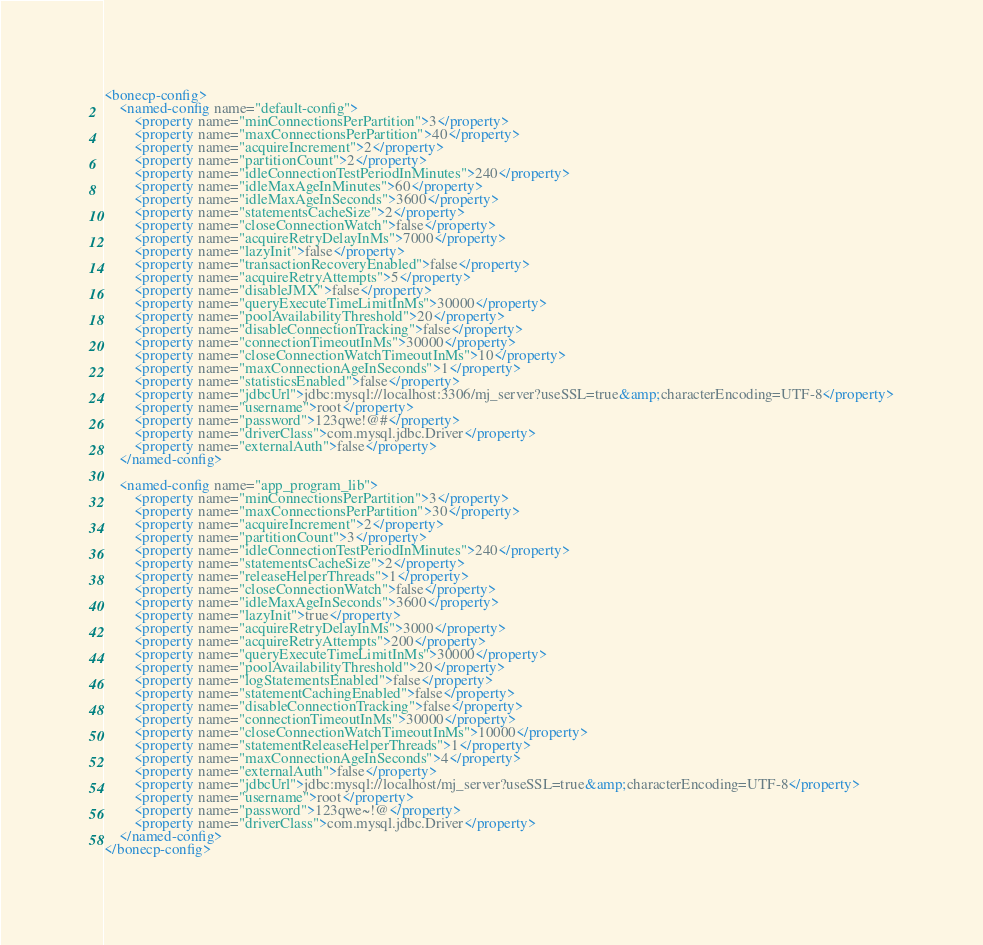<code> <loc_0><loc_0><loc_500><loc_500><_XML_><bonecp-config>
	<named-config name="default-config">
		<property name="minConnectionsPerPartition">3</property>
		<property name="maxConnectionsPerPartition">40</property>
		<property name="acquireIncrement">2</property>
		<property name="partitionCount">2</property>
		<property name="idleConnectionTestPeriodInMinutes">240</property>		 		 
		<property name="idleMaxAgeInMinutes">60</property>
		<property name="idleMaxAgeInSeconds">3600</property>
		<property name="statementsCacheSize">2</property>
		<property name="closeConnectionWatch">false</property>
		<property name="acquireRetryDelayInMs">7000</property>
		<property name="lazyInit">false</property>
		<property name="transactionRecoveryEnabled">false</property>
		<property name="acquireRetryAttempts">5</property>
		<property name="disableJMX">false</property>
		<property name="queryExecuteTimeLimitInMs">30000</property>
		<property name="poolAvailabilityThreshold">20</property>
		<property name="disableConnectionTracking">false</property>
		<property name="connectionTimeoutInMs">30000</property>
		<property name="closeConnectionWatchTimeoutInMs">10</property>
		<property name="maxConnectionAgeInSeconds">1</property>
		<property name="statisticsEnabled">false</property>
		<property name="jdbcUrl">jdbc:mysql://localhost:3306/mj_server?useSSL=true&amp;characterEncoding=UTF-8</property>
		<property name="username">root</property>
		<property name="password">123qwe!@#</property>
		<property name="driverClass">com.mysql.jdbc.Driver</property>
		<property name="externalAuth">false</property>
	</named-config>
	
	<named-config name="app_program_lib">	
		<property name="minConnectionsPerPartition">3</property>
		<property name="maxConnectionsPerPartition">30</property>
		<property name="acquireIncrement">2</property>
		<property name="partitionCount">3</property>
		<property name="idleConnectionTestPeriodInMinutes">240</property>		 		 
		<property name="statementsCacheSize">2</property>
		<property name="releaseHelperThreads">1</property>
		<property name="closeConnectionWatch">false</property>
		<property name="idleMaxAgeInSeconds">3600</property>
		<property name="lazyInit">true</property>
		<property name="acquireRetryDelayInMs">3000</property>
		<property name="acquireRetryAttempts">200</property>
		<property name="queryExecuteTimeLimitInMs">30000</property>
		<property name="poolAvailabilityThreshold">20</property>
		<property name="logStatementsEnabled">false</property>
		<property name="statementCachingEnabled">false</property>
		<property name="disableConnectionTracking">false</property>
		<property name="connectionTimeoutInMs">30000</property>
		<property name="closeConnectionWatchTimeoutInMs">10000</property>
		<property name="statementReleaseHelperThreads">1</property>
		<property name="maxConnectionAgeInSeconds">4</property>
		<property name="externalAuth">false</property>
		<property name="jdbcUrl">jdbc:mysql://localhost/mj_server?useSSL=true&amp;characterEncoding=UTF-8</property>
		<property name="username">root</property>
		<property name="password">123qwe~!@</property>
		<property name="driverClass">com.mysql.jdbc.Driver</property>		
	</named-config>
</bonecp-config></code> 